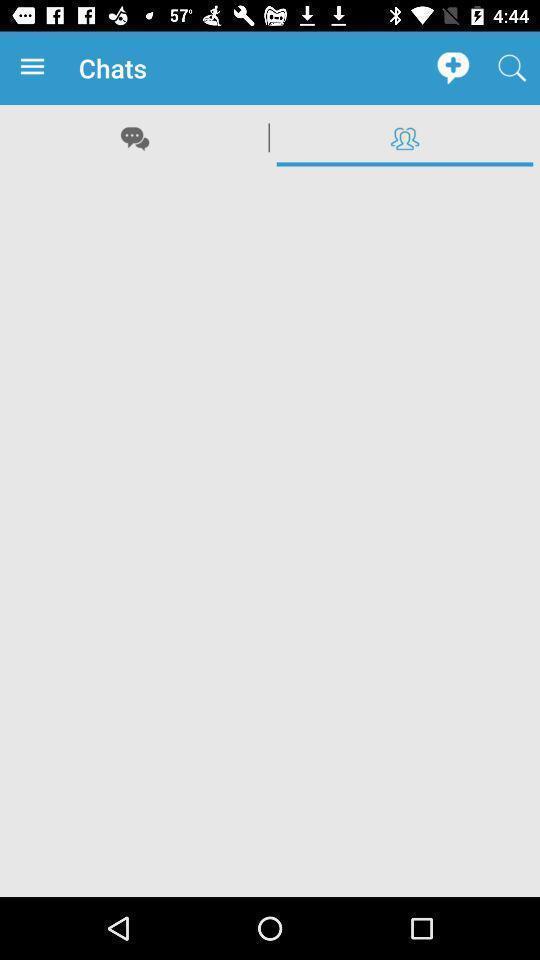Summarize the information in this screenshot. Page showing blank page in friends list of social app. 